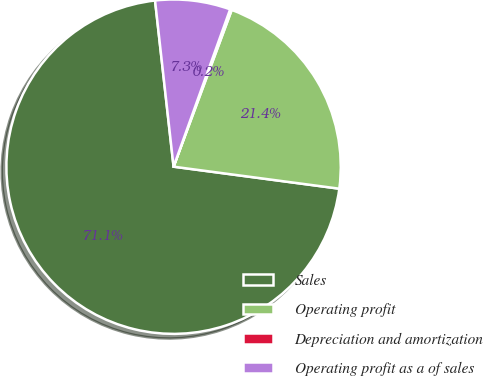<chart> <loc_0><loc_0><loc_500><loc_500><pie_chart><fcel>Sales<fcel>Operating profit<fcel>Depreciation and amortization<fcel>Operating profit as a of sales<nl><fcel>71.13%<fcel>21.45%<fcel>0.16%<fcel>7.26%<nl></chart> 